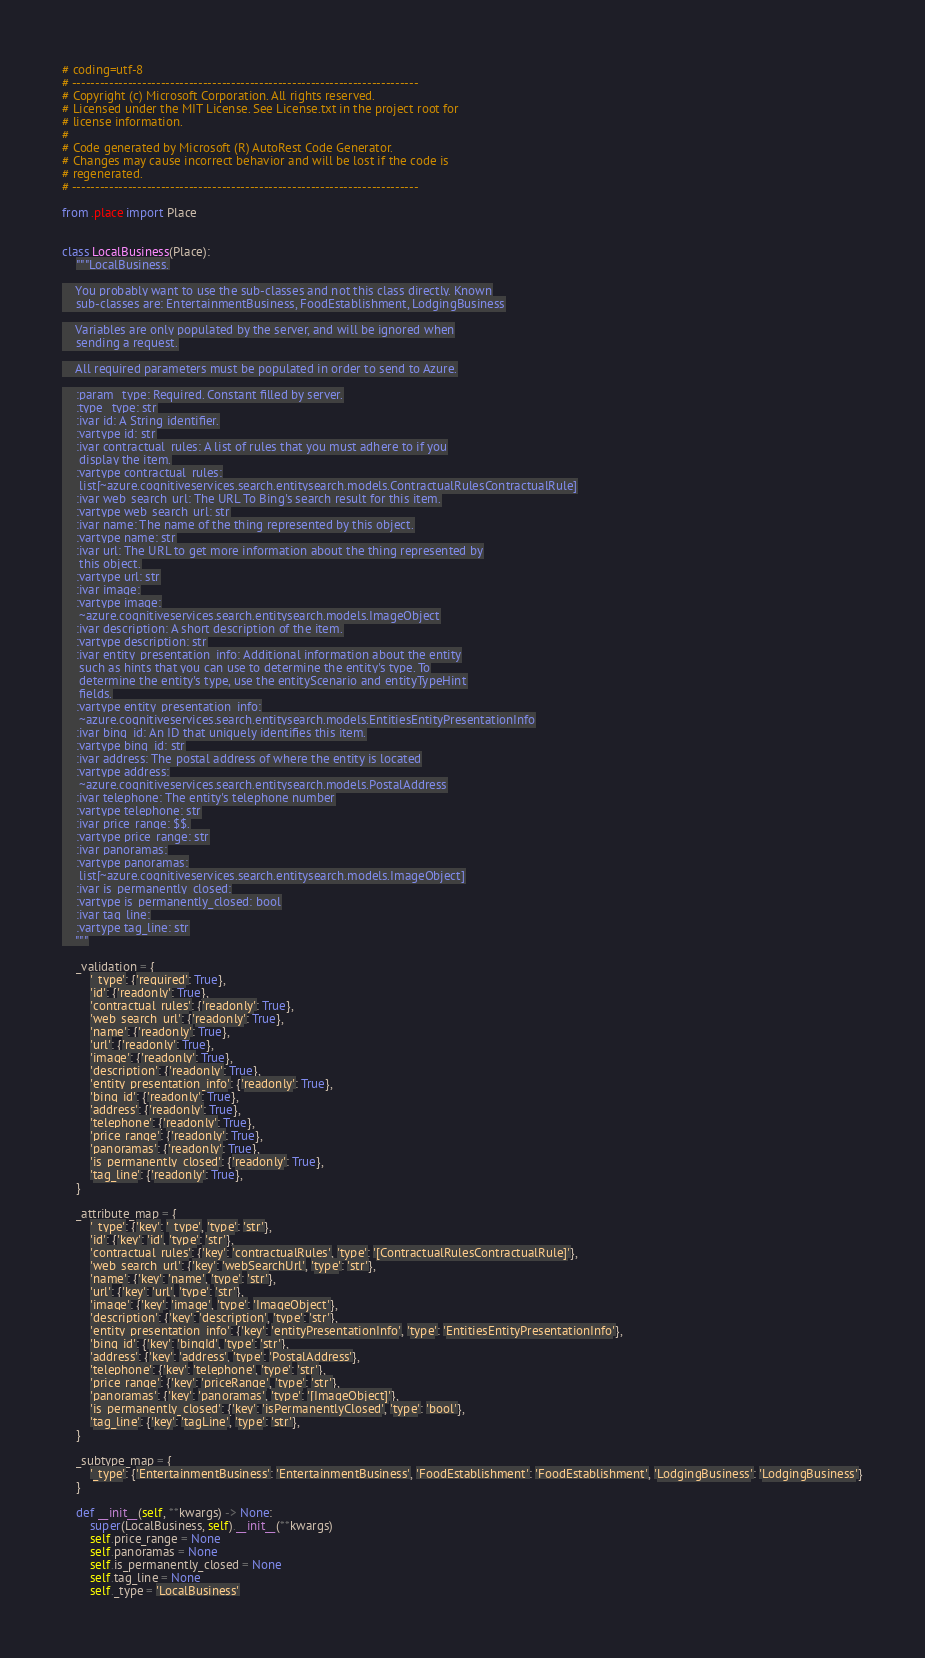<code> <loc_0><loc_0><loc_500><loc_500><_Python_># coding=utf-8
# --------------------------------------------------------------------------
# Copyright (c) Microsoft Corporation. All rights reserved.
# Licensed under the MIT License. See License.txt in the project root for
# license information.
#
# Code generated by Microsoft (R) AutoRest Code Generator.
# Changes may cause incorrect behavior and will be lost if the code is
# regenerated.
# --------------------------------------------------------------------------

from .place import Place


class LocalBusiness(Place):
    """LocalBusiness.

    You probably want to use the sub-classes and not this class directly. Known
    sub-classes are: EntertainmentBusiness, FoodEstablishment, LodgingBusiness

    Variables are only populated by the server, and will be ignored when
    sending a request.

    All required parameters must be populated in order to send to Azure.

    :param _type: Required. Constant filled by server.
    :type _type: str
    :ivar id: A String identifier.
    :vartype id: str
    :ivar contractual_rules: A list of rules that you must adhere to if you
     display the item.
    :vartype contractual_rules:
     list[~azure.cognitiveservices.search.entitysearch.models.ContractualRulesContractualRule]
    :ivar web_search_url: The URL To Bing's search result for this item.
    :vartype web_search_url: str
    :ivar name: The name of the thing represented by this object.
    :vartype name: str
    :ivar url: The URL to get more information about the thing represented by
     this object.
    :vartype url: str
    :ivar image:
    :vartype image:
     ~azure.cognitiveservices.search.entitysearch.models.ImageObject
    :ivar description: A short description of the item.
    :vartype description: str
    :ivar entity_presentation_info: Additional information about the entity
     such as hints that you can use to determine the entity's type. To
     determine the entity's type, use the entityScenario and entityTypeHint
     fields.
    :vartype entity_presentation_info:
     ~azure.cognitiveservices.search.entitysearch.models.EntitiesEntityPresentationInfo
    :ivar bing_id: An ID that uniquely identifies this item.
    :vartype bing_id: str
    :ivar address: The postal address of where the entity is located
    :vartype address:
     ~azure.cognitiveservices.search.entitysearch.models.PostalAddress
    :ivar telephone: The entity's telephone number
    :vartype telephone: str
    :ivar price_range: $$.
    :vartype price_range: str
    :ivar panoramas:
    :vartype panoramas:
     list[~azure.cognitiveservices.search.entitysearch.models.ImageObject]
    :ivar is_permanently_closed:
    :vartype is_permanently_closed: bool
    :ivar tag_line:
    :vartype tag_line: str
    """

    _validation = {
        '_type': {'required': True},
        'id': {'readonly': True},
        'contractual_rules': {'readonly': True},
        'web_search_url': {'readonly': True},
        'name': {'readonly': True},
        'url': {'readonly': True},
        'image': {'readonly': True},
        'description': {'readonly': True},
        'entity_presentation_info': {'readonly': True},
        'bing_id': {'readonly': True},
        'address': {'readonly': True},
        'telephone': {'readonly': True},
        'price_range': {'readonly': True},
        'panoramas': {'readonly': True},
        'is_permanently_closed': {'readonly': True},
        'tag_line': {'readonly': True},
    }

    _attribute_map = {
        '_type': {'key': '_type', 'type': 'str'},
        'id': {'key': 'id', 'type': 'str'},
        'contractual_rules': {'key': 'contractualRules', 'type': '[ContractualRulesContractualRule]'},
        'web_search_url': {'key': 'webSearchUrl', 'type': 'str'},
        'name': {'key': 'name', 'type': 'str'},
        'url': {'key': 'url', 'type': 'str'},
        'image': {'key': 'image', 'type': 'ImageObject'},
        'description': {'key': 'description', 'type': 'str'},
        'entity_presentation_info': {'key': 'entityPresentationInfo', 'type': 'EntitiesEntityPresentationInfo'},
        'bing_id': {'key': 'bingId', 'type': 'str'},
        'address': {'key': 'address', 'type': 'PostalAddress'},
        'telephone': {'key': 'telephone', 'type': 'str'},
        'price_range': {'key': 'priceRange', 'type': 'str'},
        'panoramas': {'key': 'panoramas', 'type': '[ImageObject]'},
        'is_permanently_closed': {'key': 'isPermanentlyClosed', 'type': 'bool'},
        'tag_line': {'key': 'tagLine', 'type': 'str'},
    }

    _subtype_map = {
        '_type': {'EntertainmentBusiness': 'EntertainmentBusiness', 'FoodEstablishment': 'FoodEstablishment', 'LodgingBusiness': 'LodgingBusiness'}
    }

    def __init__(self, **kwargs) -> None:
        super(LocalBusiness, self).__init__(**kwargs)
        self.price_range = None
        self.panoramas = None
        self.is_permanently_closed = None
        self.tag_line = None
        self._type = 'LocalBusiness'
</code> 